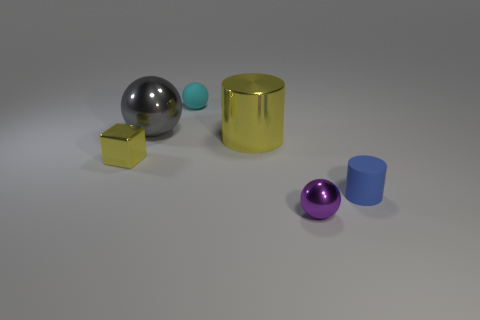Add 3 yellow matte objects. How many objects exist? 9 Subtract all blocks. How many objects are left? 5 Add 1 tiny purple things. How many tiny purple things are left? 2 Add 4 tiny yellow things. How many tiny yellow things exist? 5 Subtract 0 purple blocks. How many objects are left? 6 Subtract all tiny blue rubber cylinders. Subtract all small purple metal balls. How many objects are left? 4 